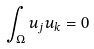<formula> <loc_0><loc_0><loc_500><loc_500>\int _ { \Omega } u _ { j } u _ { k } = 0</formula> 